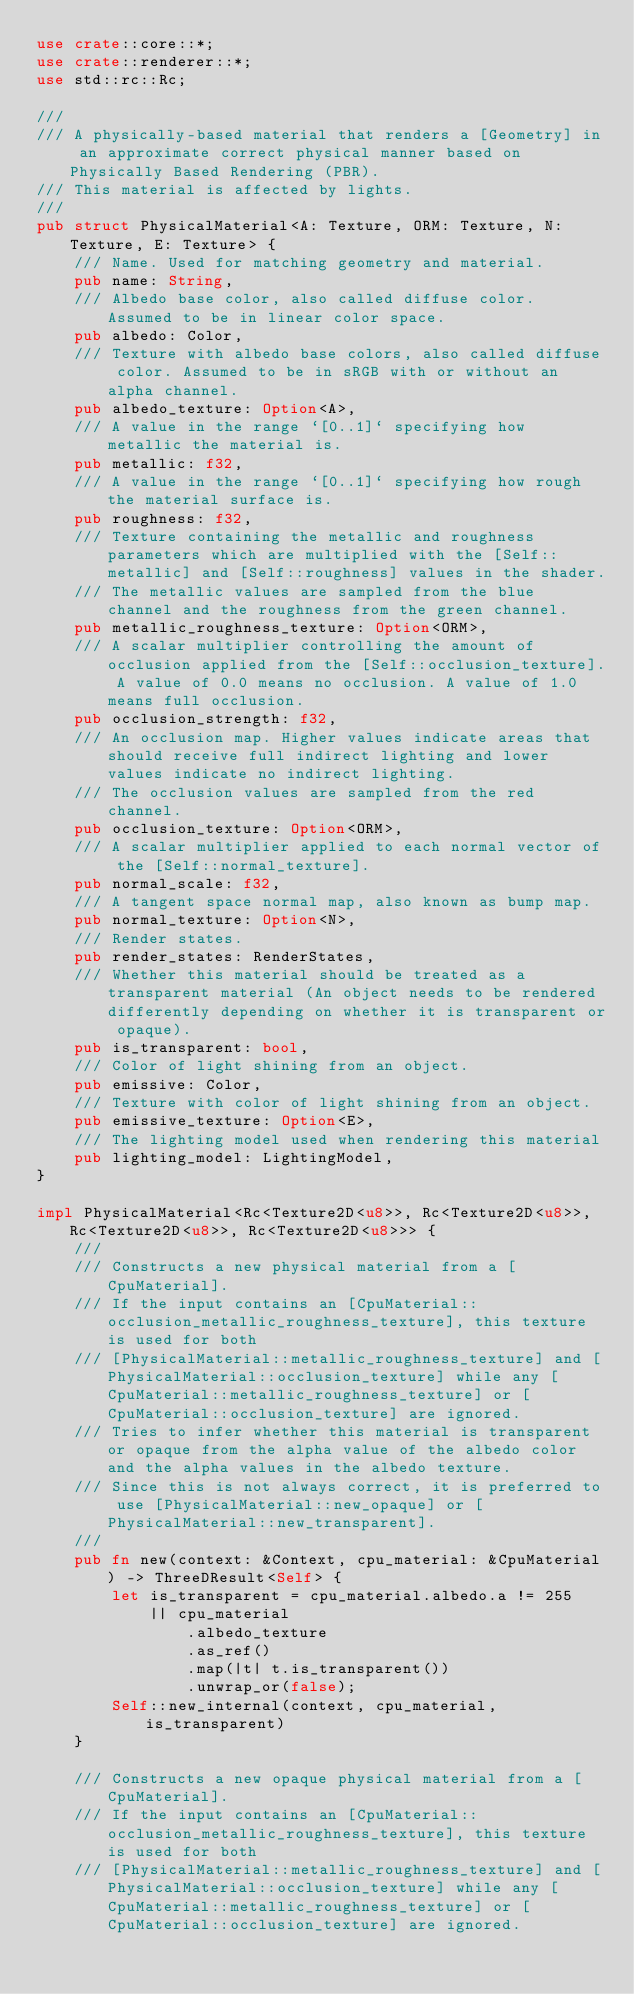<code> <loc_0><loc_0><loc_500><loc_500><_Rust_>use crate::core::*;
use crate::renderer::*;
use std::rc::Rc;

///
/// A physically-based material that renders a [Geometry] in an approximate correct physical manner based on Physically Based Rendering (PBR).
/// This material is affected by lights.
///
pub struct PhysicalMaterial<A: Texture, ORM: Texture, N: Texture, E: Texture> {
    /// Name. Used for matching geometry and material.
    pub name: String,
    /// Albedo base color, also called diffuse color. Assumed to be in linear color space.
    pub albedo: Color,
    /// Texture with albedo base colors, also called diffuse color. Assumed to be in sRGB with or without an alpha channel.
    pub albedo_texture: Option<A>,
    /// A value in the range `[0..1]` specifying how metallic the material is.
    pub metallic: f32,
    /// A value in the range `[0..1]` specifying how rough the material surface is.
    pub roughness: f32,
    /// Texture containing the metallic and roughness parameters which are multiplied with the [Self::metallic] and [Self::roughness] values in the shader.
    /// The metallic values are sampled from the blue channel and the roughness from the green channel.
    pub metallic_roughness_texture: Option<ORM>,
    /// A scalar multiplier controlling the amount of occlusion applied from the [Self::occlusion_texture]. A value of 0.0 means no occlusion. A value of 1.0 means full occlusion.
    pub occlusion_strength: f32,
    /// An occlusion map. Higher values indicate areas that should receive full indirect lighting and lower values indicate no indirect lighting.
    /// The occlusion values are sampled from the red channel.
    pub occlusion_texture: Option<ORM>,
    /// A scalar multiplier applied to each normal vector of the [Self::normal_texture].
    pub normal_scale: f32,
    /// A tangent space normal map, also known as bump map.
    pub normal_texture: Option<N>,
    /// Render states.
    pub render_states: RenderStates,
    /// Whether this material should be treated as a transparent material (An object needs to be rendered differently depending on whether it is transparent or opaque).
    pub is_transparent: bool,
    /// Color of light shining from an object.
    pub emissive: Color,
    /// Texture with color of light shining from an object.
    pub emissive_texture: Option<E>,
    /// The lighting model used when rendering this material
    pub lighting_model: LightingModel,
}

impl PhysicalMaterial<Rc<Texture2D<u8>>, Rc<Texture2D<u8>>, Rc<Texture2D<u8>>, Rc<Texture2D<u8>>> {
    ///
    /// Constructs a new physical material from a [CpuMaterial].
    /// If the input contains an [CpuMaterial::occlusion_metallic_roughness_texture], this texture is used for both
    /// [PhysicalMaterial::metallic_roughness_texture] and [PhysicalMaterial::occlusion_texture] while any [CpuMaterial::metallic_roughness_texture] or [CpuMaterial::occlusion_texture] are ignored.
    /// Tries to infer whether this material is transparent or opaque from the alpha value of the albedo color and the alpha values in the albedo texture.
    /// Since this is not always correct, it is preferred to use [PhysicalMaterial::new_opaque] or [PhysicalMaterial::new_transparent].
    ///
    pub fn new(context: &Context, cpu_material: &CpuMaterial) -> ThreeDResult<Self> {
        let is_transparent = cpu_material.albedo.a != 255
            || cpu_material
                .albedo_texture
                .as_ref()
                .map(|t| t.is_transparent())
                .unwrap_or(false);
        Self::new_internal(context, cpu_material, is_transparent)
    }

    /// Constructs a new opaque physical material from a [CpuMaterial].
    /// If the input contains an [CpuMaterial::occlusion_metallic_roughness_texture], this texture is used for both
    /// [PhysicalMaterial::metallic_roughness_texture] and [PhysicalMaterial::occlusion_texture] while any [CpuMaterial::metallic_roughness_texture] or [CpuMaterial::occlusion_texture] are ignored.</code> 